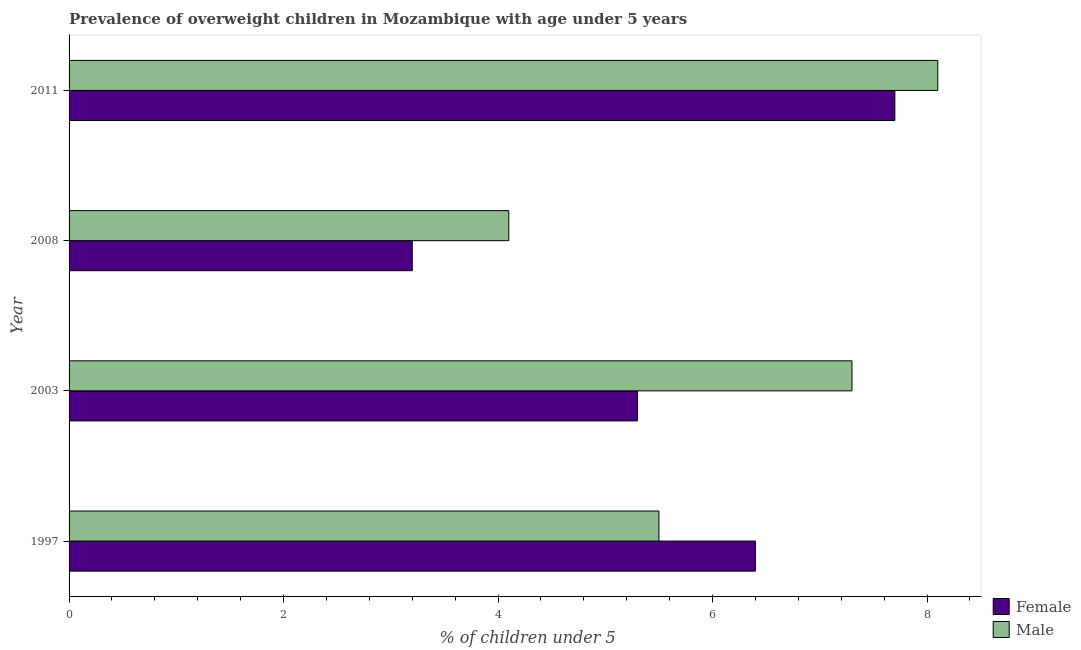How many different coloured bars are there?
Your response must be concise. 2. How many groups of bars are there?
Offer a very short reply. 4. How many bars are there on the 1st tick from the bottom?
Your answer should be very brief. 2. In how many cases, is the number of bars for a given year not equal to the number of legend labels?
Offer a very short reply. 0. What is the percentage of obese male children in 2008?
Keep it short and to the point. 4.1. Across all years, what is the maximum percentage of obese female children?
Provide a short and direct response. 7.7. Across all years, what is the minimum percentage of obese female children?
Provide a short and direct response. 3.2. In which year was the percentage of obese female children maximum?
Ensure brevity in your answer.  2011. What is the total percentage of obese female children in the graph?
Provide a succinct answer. 22.6. What is the difference between the percentage of obese male children in 2008 and the percentage of obese female children in 2011?
Offer a very short reply. -3.6. What is the average percentage of obese female children per year?
Your response must be concise. 5.65. What is the ratio of the percentage of obese male children in 1997 to that in 2008?
Ensure brevity in your answer.  1.34. Is the difference between the percentage of obese male children in 1997 and 2008 greater than the difference between the percentage of obese female children in 1997 and 2008?
Keep it short and to the point. No. What is the difference between the highest and the second highest percentage of obese male children?
Your answer should be compact. 0.8. What is the difference between the highest and the lowest percentage of obese female children?
Keep it short and to the point. 4.5. Is the sum of the percentage of obese male children in 2008 and 2011 greater than the maximum percentage of obese female children across all years?
Make the answer very short. Yes. Are all the bars in the graph horizontal?
Keep it short and to the point. Yes. How many years are there in the graph?
Give a very brief answer. 4. What is the difference between two consecutive major ticks on the X-axis?
Keep it short and to the point. 2. Does the graph contain any zero values?
Offer a terse response. No. What is the title of the graph?
Keep it short and to the point. Prevalence of overweight children in Mozambique with age under 5 years. What is the label or title of the X-axis?
Your answer should be compact.  % of children under 5. What is the  % of children under 5 of Female in 1997?
Your answer should be very brief. 6.4. What is the  % of children under 5 in Female in 2003?
Your answer should be compact. 5.3. What is the  % of children under 5 of Male in 2003?
Provide a succinct answer. 7.3. What is the  % of children under 5 of Female in 2008?
Provide a succinct answer. 3.2. What is the  % of children under 5 in Male in 2008?
Ensure brevity in your answer.  4.1. What is the  % of children under 5 of Female in 2011?
Ensure brevity in your answer.  7.7. What is the  % of children under 5 in Male in 2011?
Your answer should be very brief. 8.1. Across all years, what is the maximum  % of children under 5 of Female?
Make the answer very short. 7.7. Across all years, what is the maximum  % of children under 5 of Male?
Offer a terse response. 8.1. Across all years, what is the minimum  % of children under 5 in Female?
Your answer should be compact. 3.2. Across all years, what is the minimum  % of children under 5 in Male?
Make the answer very short. 4.1. What is the total  % of children under 5 of Female in the graph?
Your answer should be very brief. 22.6. What is the difference between the  % of children under 5 of Male in 1997 and that in 2003?
Your answer should be compact. -1.8. What is the difference between the  % of children under 5 in Female in 1997 and that in 2008?
Make the answer very short. 3.2. What is the difference between the  % of children under 5 of Male in 1997 and that in 2008?
Provide a succinct answer. 1.4. What is the difference between the  % of children under 5 of Male in 1997 and that in 2011?
Your answer should be compact. -2.6. What is the difference between the  % of children under 5 in Female in 2003 and that in 2011?
Give a very brief answer. -2.4. What is the difference between the  % of children under 5 in Male in 2003 and that in 2011?
Offer a very short reply. -0.8. What is the difference between the  % of children under 5 of Female in 1997 and the  % of children under 5 of Male in 2003?
Your answer should be compact. -0.9. What is the difference between the  % of children under 5 of Female in 1997 and the  % of children under 5 of Male in 2011?
Keep it short and to the point. -1.7. What is the difference between the  % of children under 5 of Female in 2003 and the  % of children under 5 of Male in 2008?
Provide a short and direct response. 1.2. What is the difference between the  % of children under 5 of Female in 2008 and the  % of children under 5 of Male in 2011?
Keep it short and to the point. -4.9. What is the average  % of children under 5 of Female per year?
Keep it short and to the point. 5.65. What is the average  % of children under 5 of Male per year?
Your answer should be compact. 6.25. In the year 2011, what is the difference between the  % of children under 5 of Female and  % of children under 5 of Male?
Make the answer very short. -0.4. What is the ratio of the  % of children under 5 in Female in 1997 to that in 2003?
Ensure brevity in your answer.  1.21. What is the ratio of the  % of children under 5 in Male in 1997 to that in 2003?
Provide a short and direct response. 0.75. What is the ratio of the  % of children under 5 of Male in 1997 to that in 2008?
Your response must be concise. 1.34. What is the ratio of the  % of children under 5 of Female in 1997 to that in 2011?
Provide a short and direct response. 0.83. What is the ratio of the  % of children under 5 in Male in 1997 to that in 2011?
Offer a very short reply. 0.68. What is the ratio of the  % of children under 5 in Female in 2003 to that in 2008?
Your response must be concise. 1.66. What is the ratio of the  % of children under 5 in Male in 2003 to that in 2008?
Your answer should be very brief. 1.78. What is the ratio of the  % of children under 5 in Female in 2003 to that in 2011?
Ensure brevity in your answer.  0.69. What is the ratio of the  % of children under 5 in Male in 2003 to that in 2011?
Your answer should be compact. 0.9. What is the ratio of the  % of children under 5 of Female in 2008 to that in 2011?
Keep it short and to the point. 0.42. What is the ratio of the  % of children under 5 of Male in 2008 to that in 2011?
Ensure brevity in your answer.  0.51. What is the difference between the highest and the second highest  % of children under 5 of Female?
Provide a short and direct response. 1.3. What is the difference between the highest and the lowest  % of children under 5 in Male?
Make the answer very short. 4. 